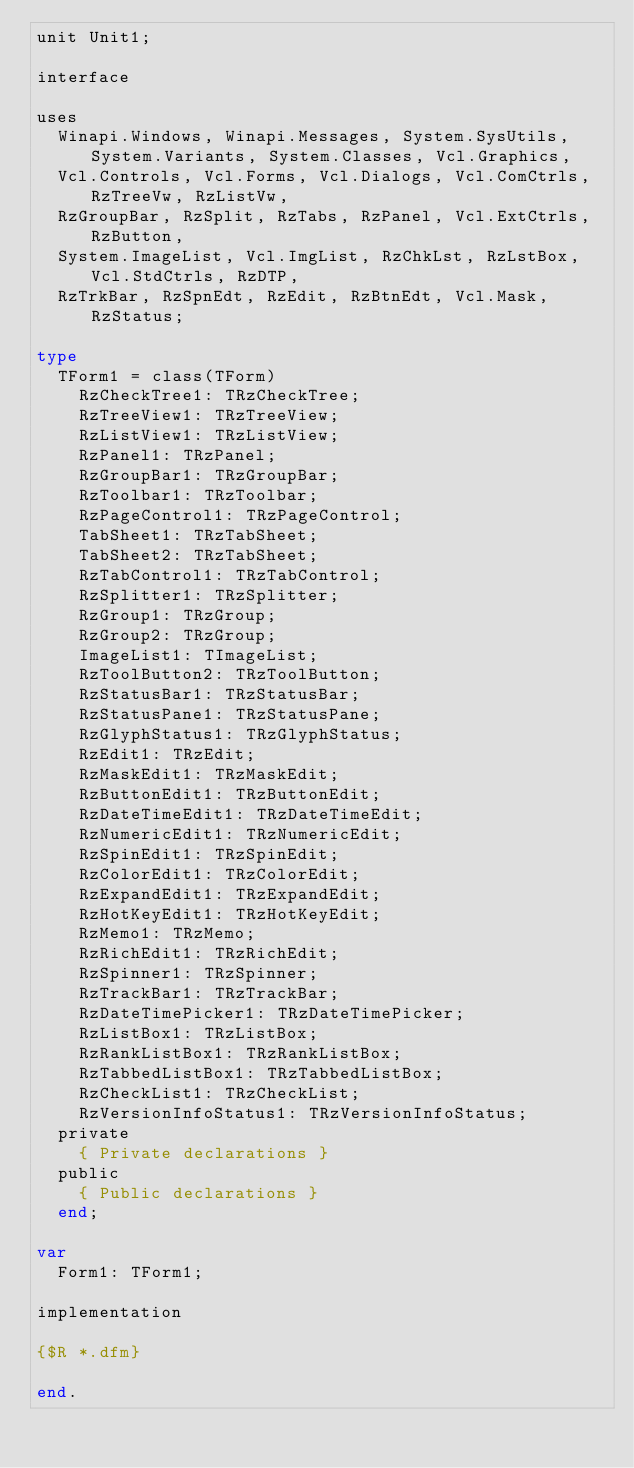Convert code to text. <code><loc_0><loc_0><loc_500><loc_500><_Pascal_>unit Unit1;

interface

uses
  Winapi.Windows, Winapi.Messages, System.SysUtils, System.Variants, System.Classes, Vcl.Graphics,
  Vcl.Controls, Vcl.Forms, Vcl.Dialogs, Vcl.ComCtrls, RzTreeVw, RzListVw,
  RzGroupBar, RzSplit, RzTabs, RzPanel, Vcl.ExtCtrls, RzButton,
  System.ImageList, Vcl.ImgList, RzChkLst, RzLstBox, Vcl.StdCtrls, RzDTP,
  RzTrkBar, RzSpnEdt, RzEdit, RzBtnEdt, Vcl.Mask, RzStatus;

type
  TForm1 = class(TForm)
    RzCheckTree1: TRzCheckTree;
    RzTreeView1: TRzTreeView;
    RzListView1: TRzListView;
    RzPanel1: TRzPanel;
    RzGroupBar1: TRzGroupBar;
    RzToolbar1: TRzToolbar;
    RzPageControl1: TRzPageControl;
    TabSheet1: TRzTabSheet;
    TabSheet2: TRzTabSheet;
    RzTabControl1: TRzTabControl;
    RzSplitter1: TRzSplitter;
    RzGroup1: TRzGroup;
    RzGroup2: TRzGroup;
    ImageList1: TImageList;
    RzToolButton2: TRzToolButton;
    RzStatusBar1: TRzStatusBar;
    RzStatusPane1: TRzStatusPane;
    RzGlyphStatus1: TRzGlyphStatus;
    RzEdit1: TRzEdit;
    RzMaskEdit1: TRzMaskEdit;
    RzButtonEdit1: TRzButtonEdit;
    RzDateTimeEdit1: TRzDateTimeEdit;
    RzNumericEdit1: TRzNumericEdit;
    RzSpinEdit1: TRzSpinEdit;
    RzColorEdit1: TRzColorEdit;
    RzExpandEdit1: TRzExpandEdit;
    RzHotKeyEdit1: TRzHotKeyEdit;
    RzMemo1: TRzMemo;
    RzRichEdit1: TRzRichEdit;
    RzSpinner1: TRzSpinner;
    RzTrackBar1: TRzTrackBar;
    RzDateTimePicker1: TRzDateTimePicker;
    RzListBox1: TRzListBox;
    RzRankListBox1: TRzRankListBox;
    RzTabbedListBox1: TRzTabbedListBox;
    RzCheckList1: TRzCheckList;
    RzVersionInfoStatus1: TRzVersionInfoStatus;
  private
    { Private declarations }
  public
    { Public declarations }
  end;

var
  Form1: TForm1;

implementation

{$R *.dfm}

end.
</code> 